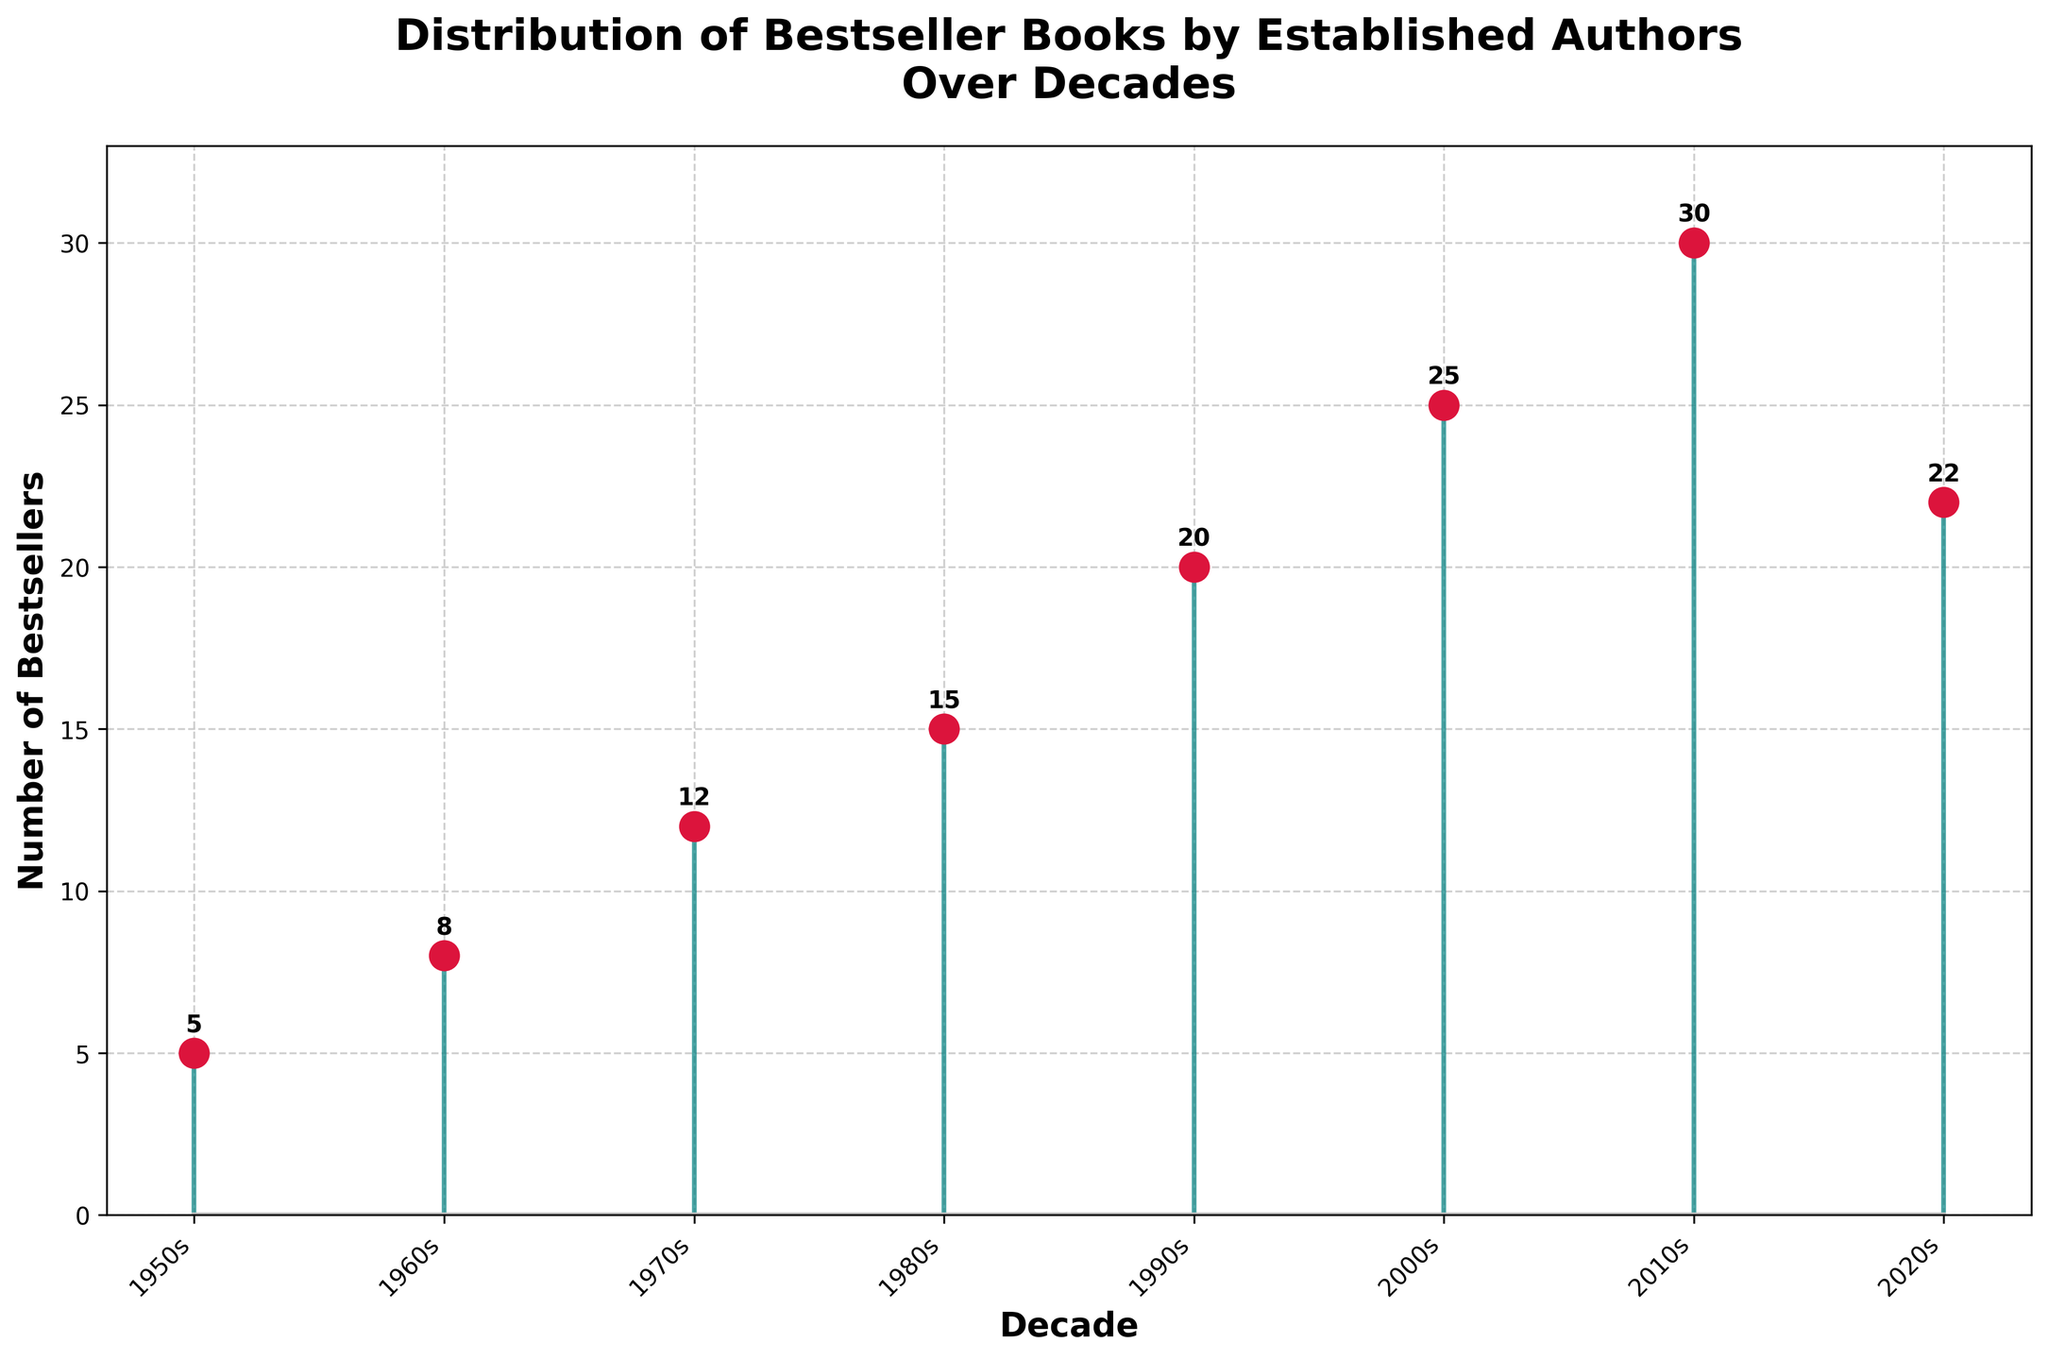What's the title of the figure? The title of the figure is shown at the top of the plot. The title reads "Distribution of Bestseller Books by Established Authors Over Decades"
Answer: Distribution of Bestseller Books by Established Authors Over Decades How many bestsellers were there in the 1980s? To find the number of bestsellers in the 1980s, refer to the data point along the x-axis labeled "1980s" and see the corresponding value on the y-axis.
Answer: 15 In which decade did the number of bestsellers first reach 20? Look for the decade on the x-axis where the corresponding value on the y-axis first reaches 20.
Answer: 1990s What is the sum of the number of bestsellers from the 2000s and the 2010s? Add the number of bestsellers from the 2000s (25) and the 2010s (30). The sum is 25 + 30.
Answer: 55 By how much did the number of bestsellers increase from the 1970s to the 2000s? Subtract the number of bestsellers in the 1970s (12) from the number in the 2000s (25). The increase is 25 - 12.
Answer: 13 Which decade experienced the highest number of bestsellers? Find the highest value on the y-axis and note the corresponding decade on the x-axis.
Answer: 2010s How does the number of bestsellers in the 2020s compare with the 2010s? Compare the values of the number of bestsellers for the 2020s (22) and the 2010s (30). The number is less in the 2020s.
Answer: The 2020s have fewer bestsellers What's the average number of bestsellers from the 1950s to the 2020s? Sum all the number of bestsellers from each decade and divide by the number of decades. (5 + 8 + 12 + 15 + 20 + 25 + 30 + 22) / 8 = 137 / 8.
Answer: 17.125 On which axes are the decades and the number of bestsellers plotted? From the figure, the x-axis represents the decades and the y-axis represents the number of bestsellers.
Answer: x-axis: decades, y-axis: number of bestsellers 